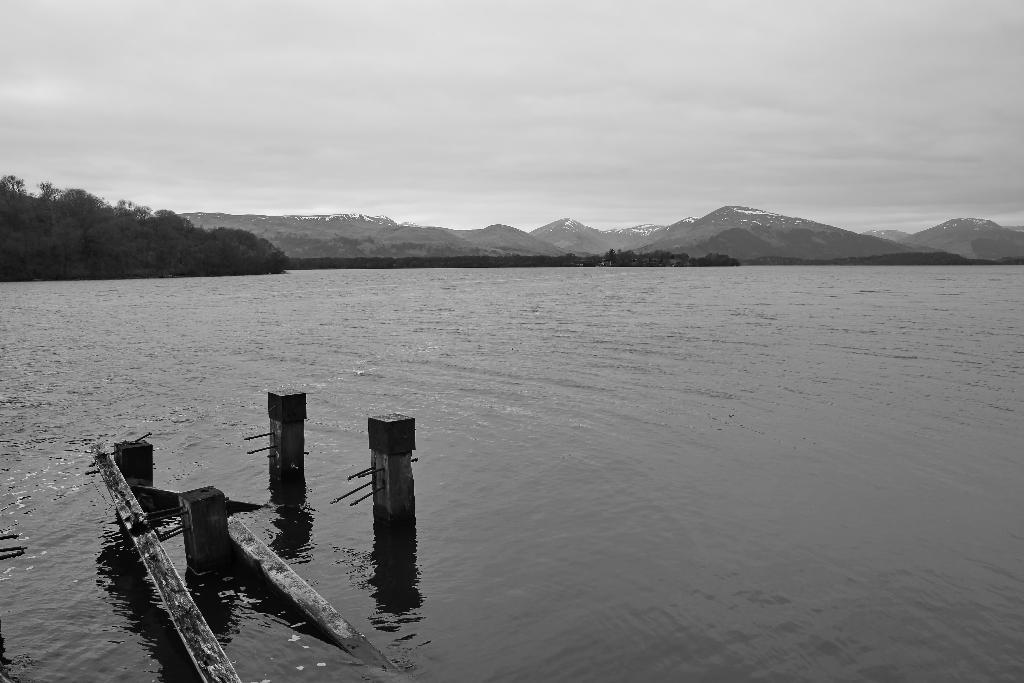What is the color scheme of the image? The image is black and white. What type of natural elements can be seen in the image? There are trees, mountains, and water (a river) in the image. What man-made structures are present in the image? There are poles in the image. What part of the natural environment is visible in the background of the image? The sky is visible in the background of the image. What type of nose can be seen on the trees in the image? There are no noses present on the trees in the image, as trees do not have noses. Is there a party happening in the image? There is no indication of a party in the image; it features natural elements and man-made structures. 